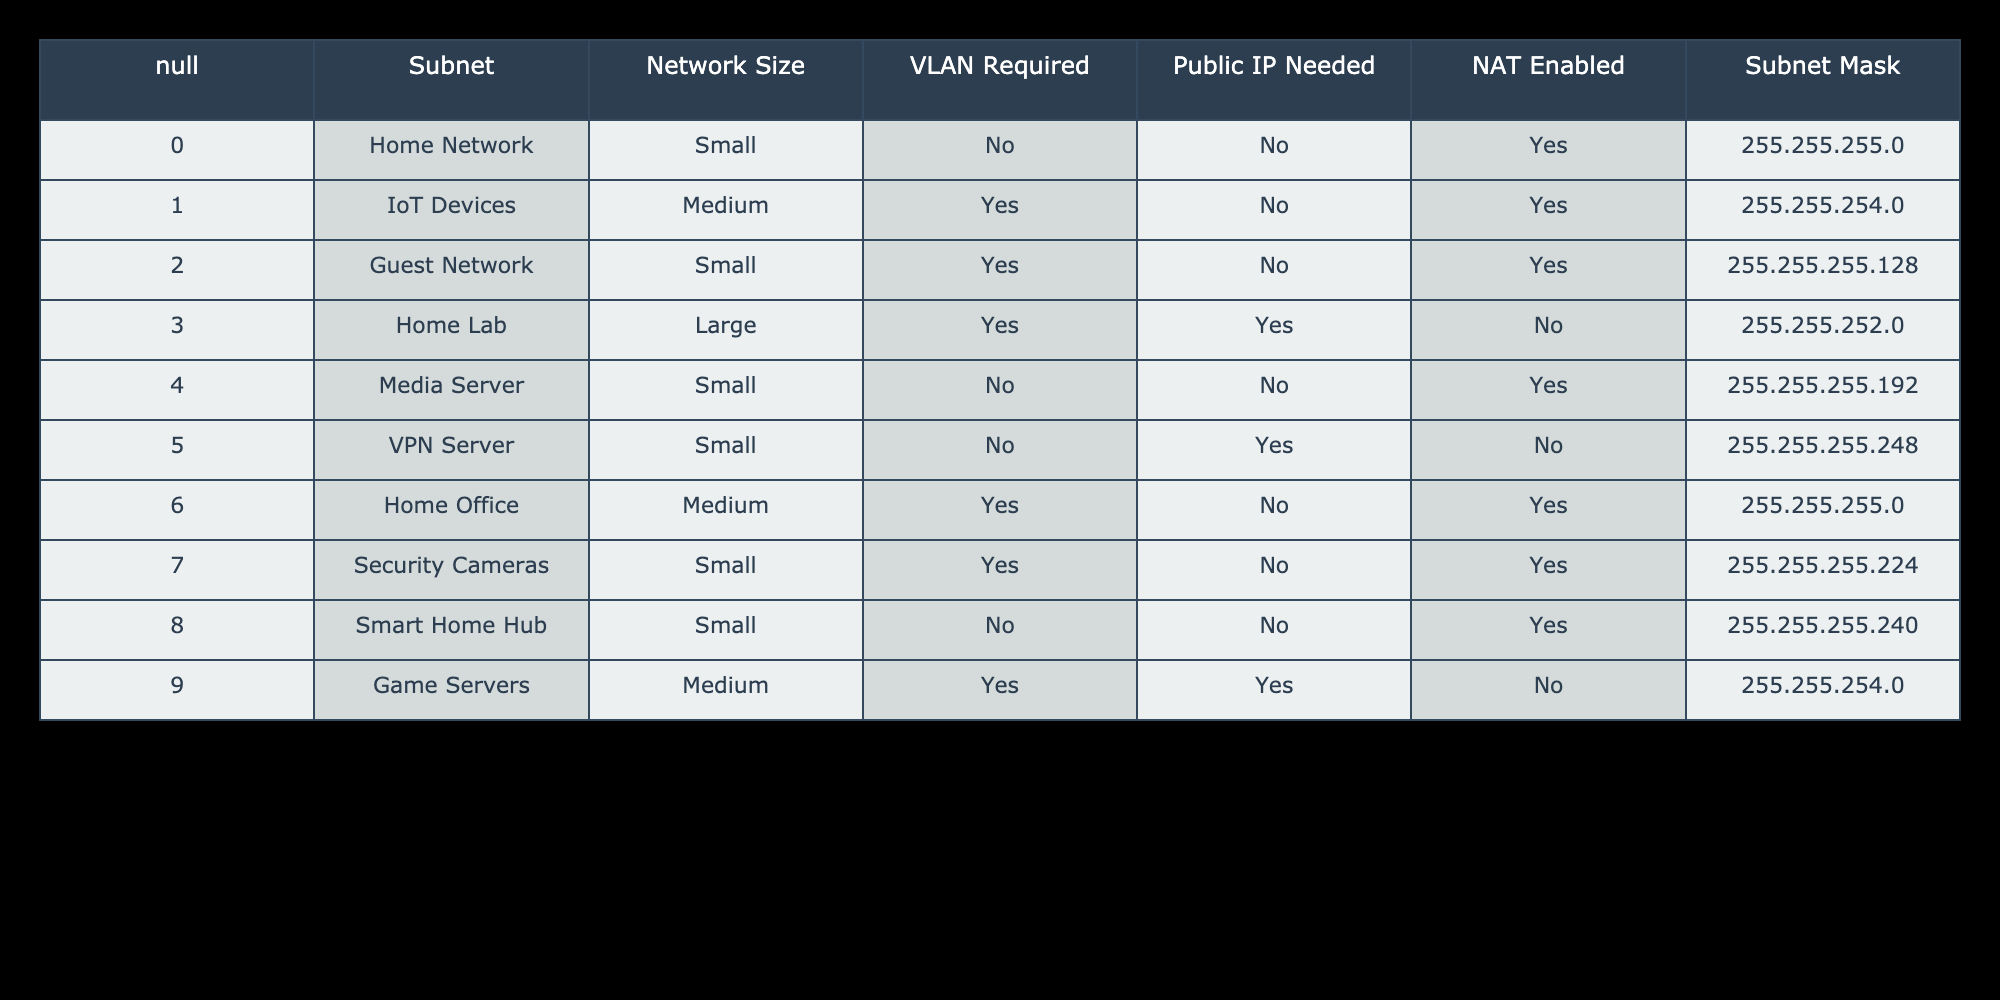What subnet mask is used for the Home Lab? From the table, we look under the Subnet Mask column for the Home Lab row. The value listed there is 255.255.252.0.
Answer: 255.255.252.0 Does the Media Server require a VLAN? We check the VLAN Required column for the Media Server row in the table. The entry is "No," indicating that a VLAN is not required.
Answer: No Which networks do not require a public IP? To find this, we must look at the Public IP Needed column and identify rows with "No." The relevant networks are Home Network, IoT Devices, Guest Network, Media Server, VPN Server, Home Office, and Smart Home Hub.
Answer: Home Network, IoT Devices, Guest Network, Media Server, VPN Server, Home Office, Smart Home Hub What is the average network size for the networks requiring a VLAN? We identify networks that require a VLAN, which are IoT Devices, Guest Network, Home Lab, Home Office, and Security Cameras. They are of medium, small, large, medium, and small sizes respectively. Converting to numerical values (Small=1, Medium=2, Large=3): 2 + 1 + 3 + 2 + 1 = 9. Dividing by the number of networks (5) gives us 9/5 = 1.8.
Answer: 1.8 How many of the listed networks have NAT enabled? We search the NAT Enabled column for "Yes." The networks that have NAT enabled are Home Network, IoT Devices, Guest Network, Home Office, Security Cameras, and Smart Home Hub, totaling six networks.
Answer: 6 What routing protocol is typically used for a large network such as Home Lab? While the table doesn't specify routing protocols, large networks commonly benefit from protocols that handle scalability and complex routing. For the Home Lab, typical choices could include OSPF or EIGRP based on the size and requirements in practice.
Answer: Typically OSPF or EIGRP Is the Guest Network larger than the Media Server network? The Guest Network is listed as Small, while the Media Server is also Small. Since they are the same size, we conclude that the Guest Network is not larger than the Media Server network.
Answer: No How many networks have public IPs assigned? We review the Public IP Needed column for networks requiring a public IP, which includes Home Lab and VPN Server, totaling two networks.
Answer: 2 